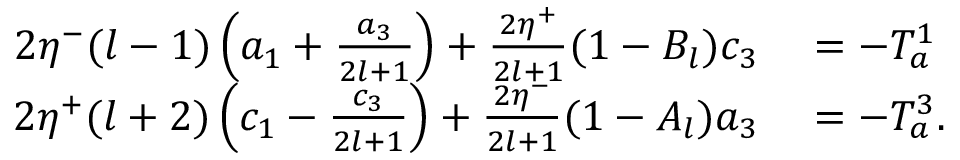<formula> <loc_0><loc_0><loc_500><loc_500>\begin{array} { r l } { 2 \eta ^ { - } ( l - 1 ) \left ( a _ { 1 } + \frac { a _ { 3 } } { 2 l + 1 } \right ) + \frac { 2 \eta ^ { + } } { 2 l + 1 } ( 1 - B _ { l } ) c _ { 3 } } & = - T _ { a } ^ { 1 } } \\ { 2 \eta ^ { + } ( l + 2 ) \left ( c _ { 1 } - \frac { c _ { 3 } } { 2 l + 1 } \right ) + \frac { 2 \eta ^ { - } } { 2 l + 1 } ( 1 - A _ { l } ) a _ { 3 } } & = - T _ { a } ^ { 3 } . } \end{array}</formula> 